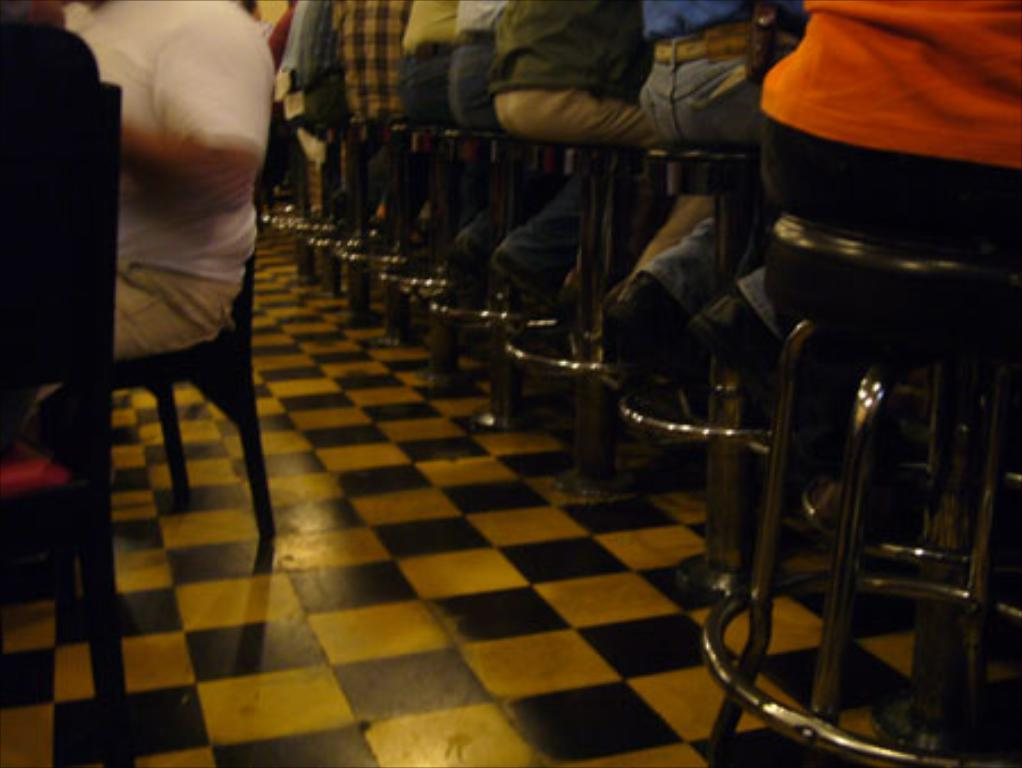What is the main subject of the image? The main subject of the image is people. What are the people doing in the image? The people are seated on stools. Can you describe the position of the people in the image? Their backs are visible. What type of pies are being served to the people in the image? There is no mention of pies in the image, so it cannot be determined if any are being served. 